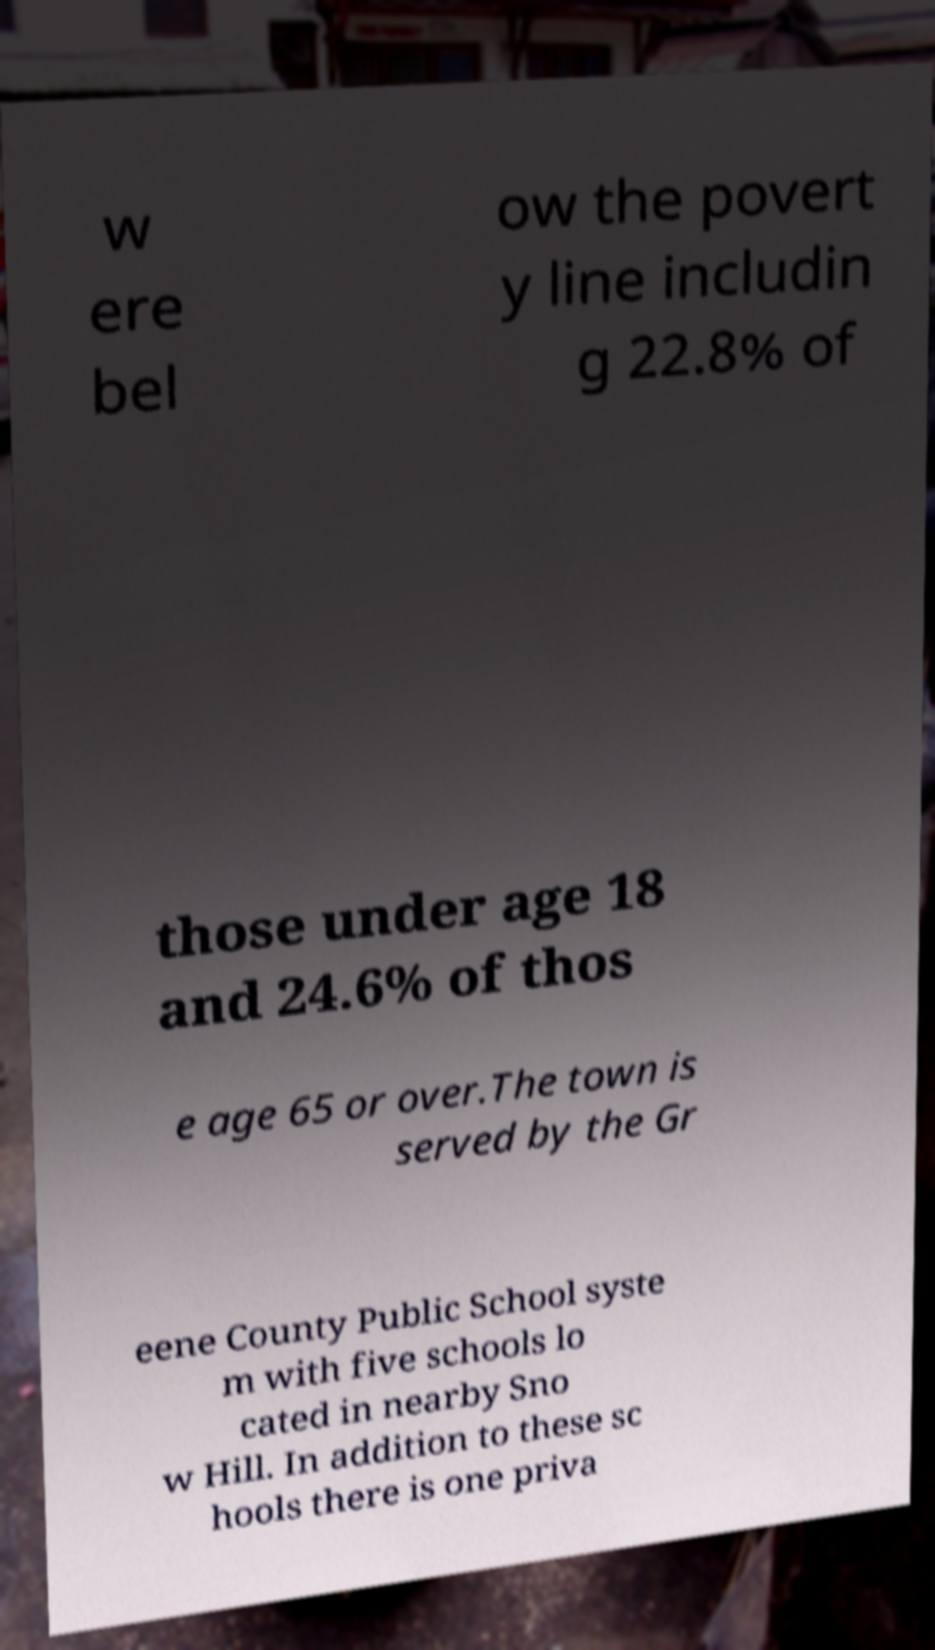I need the written content from this picture converted into text. Can you do that? w ere bel ow the povert y line includin g 22.8% of those under age 18 and 24.6% of thos e age 65 or over.The town is served by the Gr eene County Public School syste m with five schools lo cated in nearby Sno w Hill. In addition to these sc hools there is one priva 